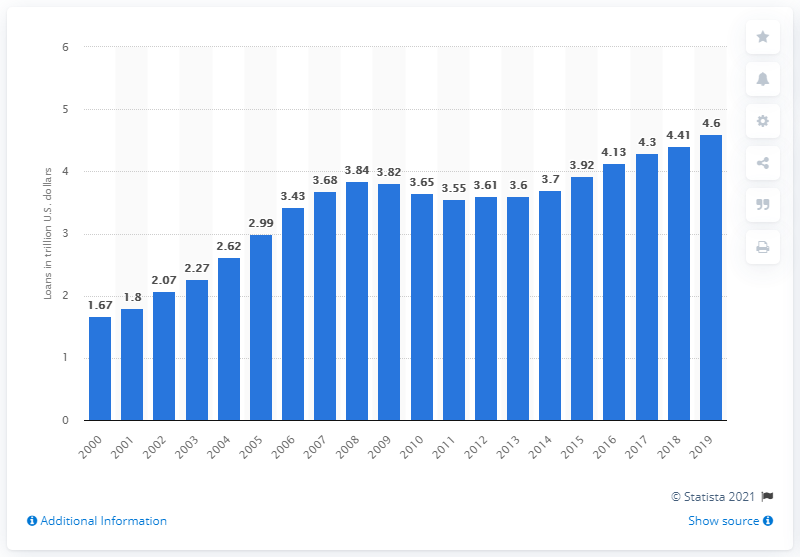Highlight a few significant elements in this photo. In 2019, the value of loans made by FDIC-insured commercial banks that were secured by real estate was approximately $4.6 trillion. 